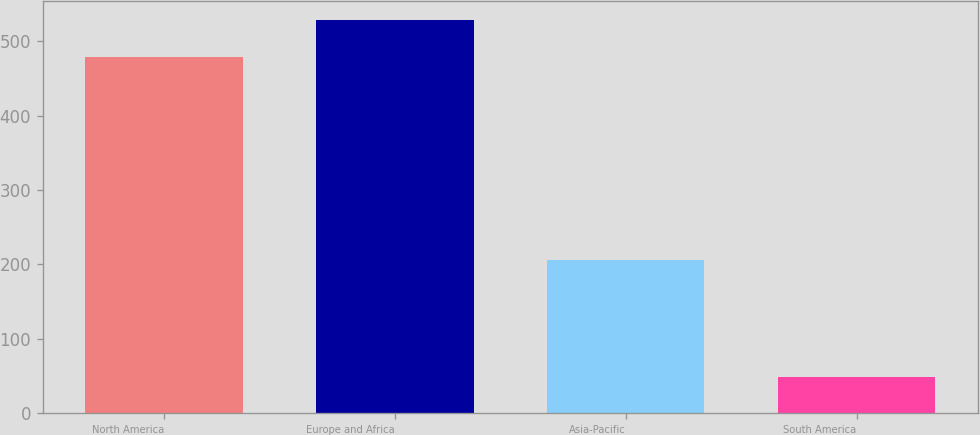Convert chart. <chart><loc_0><loc_0><loc_500><loc_500><bar_chart><fcel>North America<fcel>Europe and Africa<fcel>Asia-Pacific<fcel>South America<nl><fcel>478<fcel>528<fcel>206<fcel>49<nl></chart> 